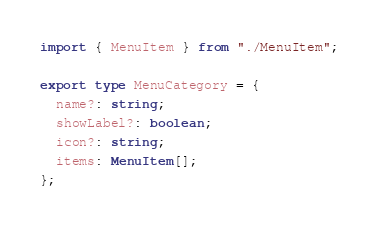Convert code to text. <code><loc_0><loc_0><loc_500><loc_500><_TypeScript_>import { MenuItem } from "./MenuItem";

export type MenuCategory = {
  name?: string;
  showLabel?: boolean;
  icon?: string;
  items: MenuItem[];
};
</code> 